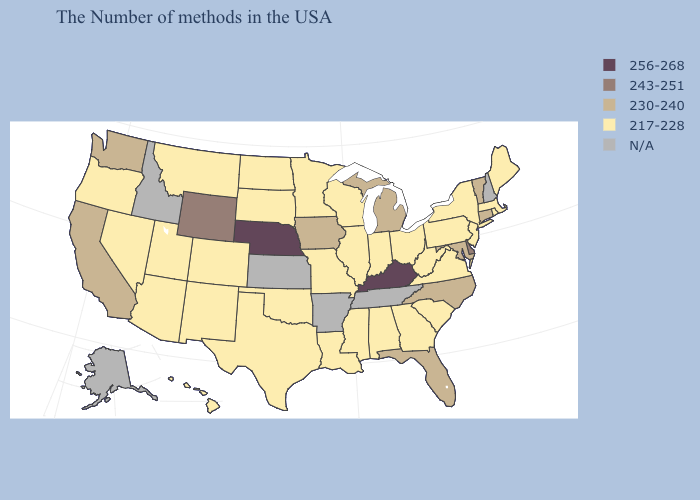Name the states that have a value in the range 256-268?
Be succinct. Kentucky, Nebraska. Name the states that have a value in the range 230-240?
Be succinct. Vermont, Connecticut, Maryland, North Carolina, Florida, Michigan, Iowa, California, Washington. Among the states that border Utah , which have the lowest value?
Be succinct. Colorado, New Mexico, Arizona, Nevada. Is the legend a continuous bar?
Be succinct. No. What is the highest value in the MidWest ?
Quick response, please. 256-268. What is the highest value in the MidWest ?
Short answer required. 256-268. Name the states that have a value in the range N/A?
Quick response, please. New Hampshire, Tennessee, Arkansas, Kansas, Idaho, Alaska. What is the highest value in the MidWest ?
Write a very short answer. 256-268. What is the highest value in the USA?
Be succinct. 256-268. What is the lowest value in states that border Oklahoma?
Be succinct. 217-228. What is the value of Idaho?
Keep it brief. N/A. What is the highest value in the USA?
Be succinct. 256-268. What is the lowest value in the USA?
Keep it brief. 217-228. Does Nebraska have the highest value in the USA?
Answer briefly. Yes. What is the highest value in states that border Arizona?
Concise answer only. 230-240. 